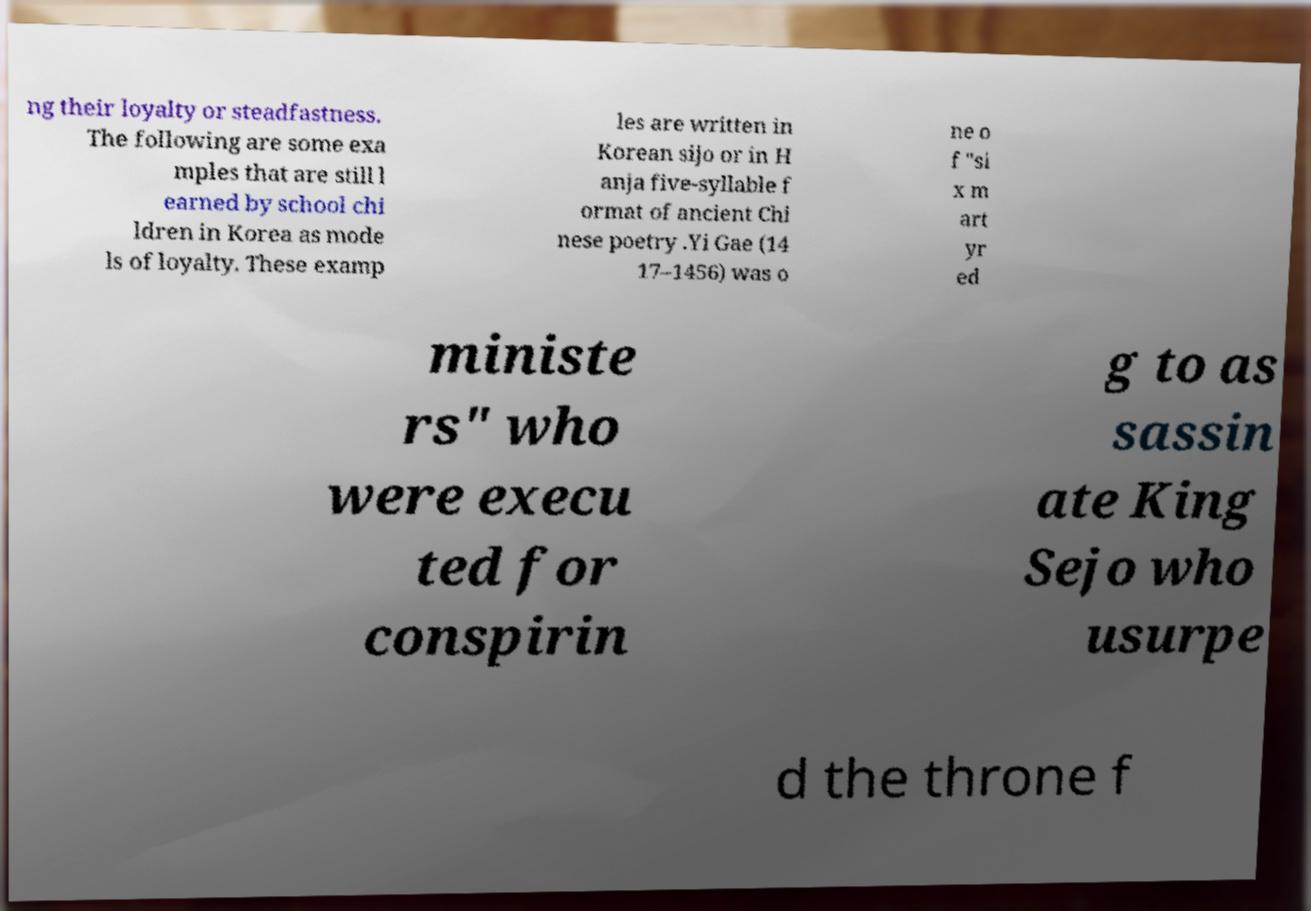Please identify and transcribe the text found in this image. ng their loyalty or steadfastness. The following are some exa mples that are still l earned by school chi ldren in Korea as mode ls of loyalty. These examp les are written in Korean sijo or in H anja five-syllable f ormat of ancient Chi nese poetry .Yi Gae (14 17–1456) was o ne o f "si x m art yr ed ministe rs" who were execu ted for conspirin g to as sassin ate King Sejo who usurpe d the throne f 